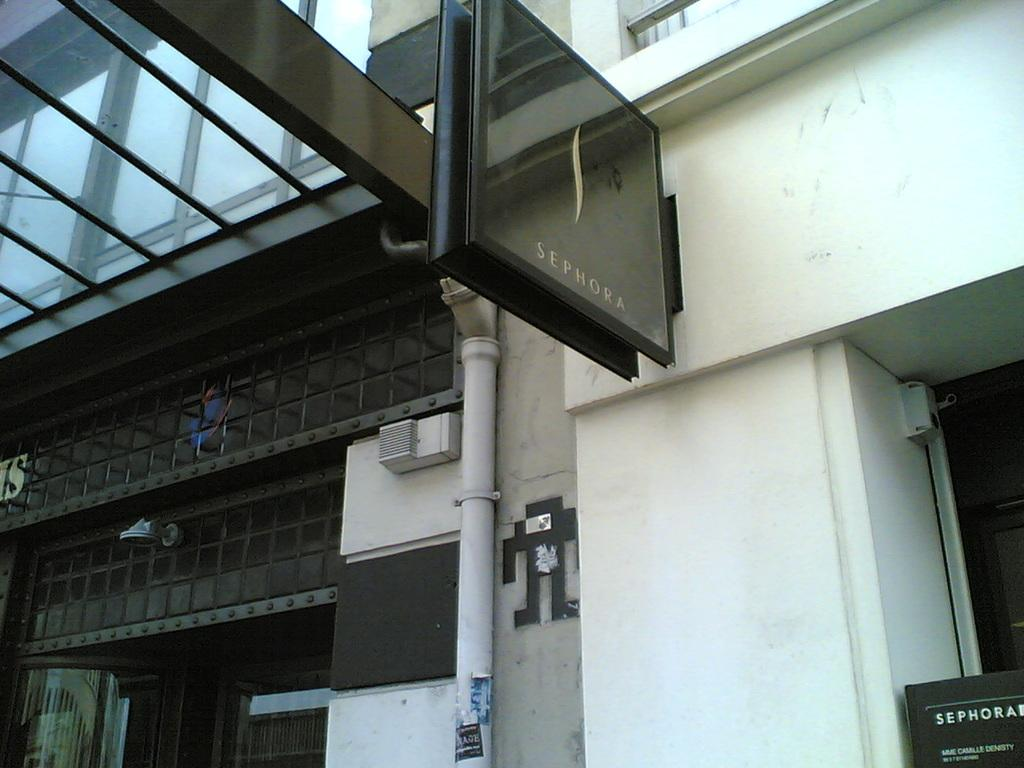What is the main subject in the center of the image? There is a building in the center of the image. What is placed on the wall of the building? There is a board placed on the wall of the building. Can you see your friend waxing the building in the image? There is no friend or waxing activity present in the image; it only shows a building with a board on its wall. 